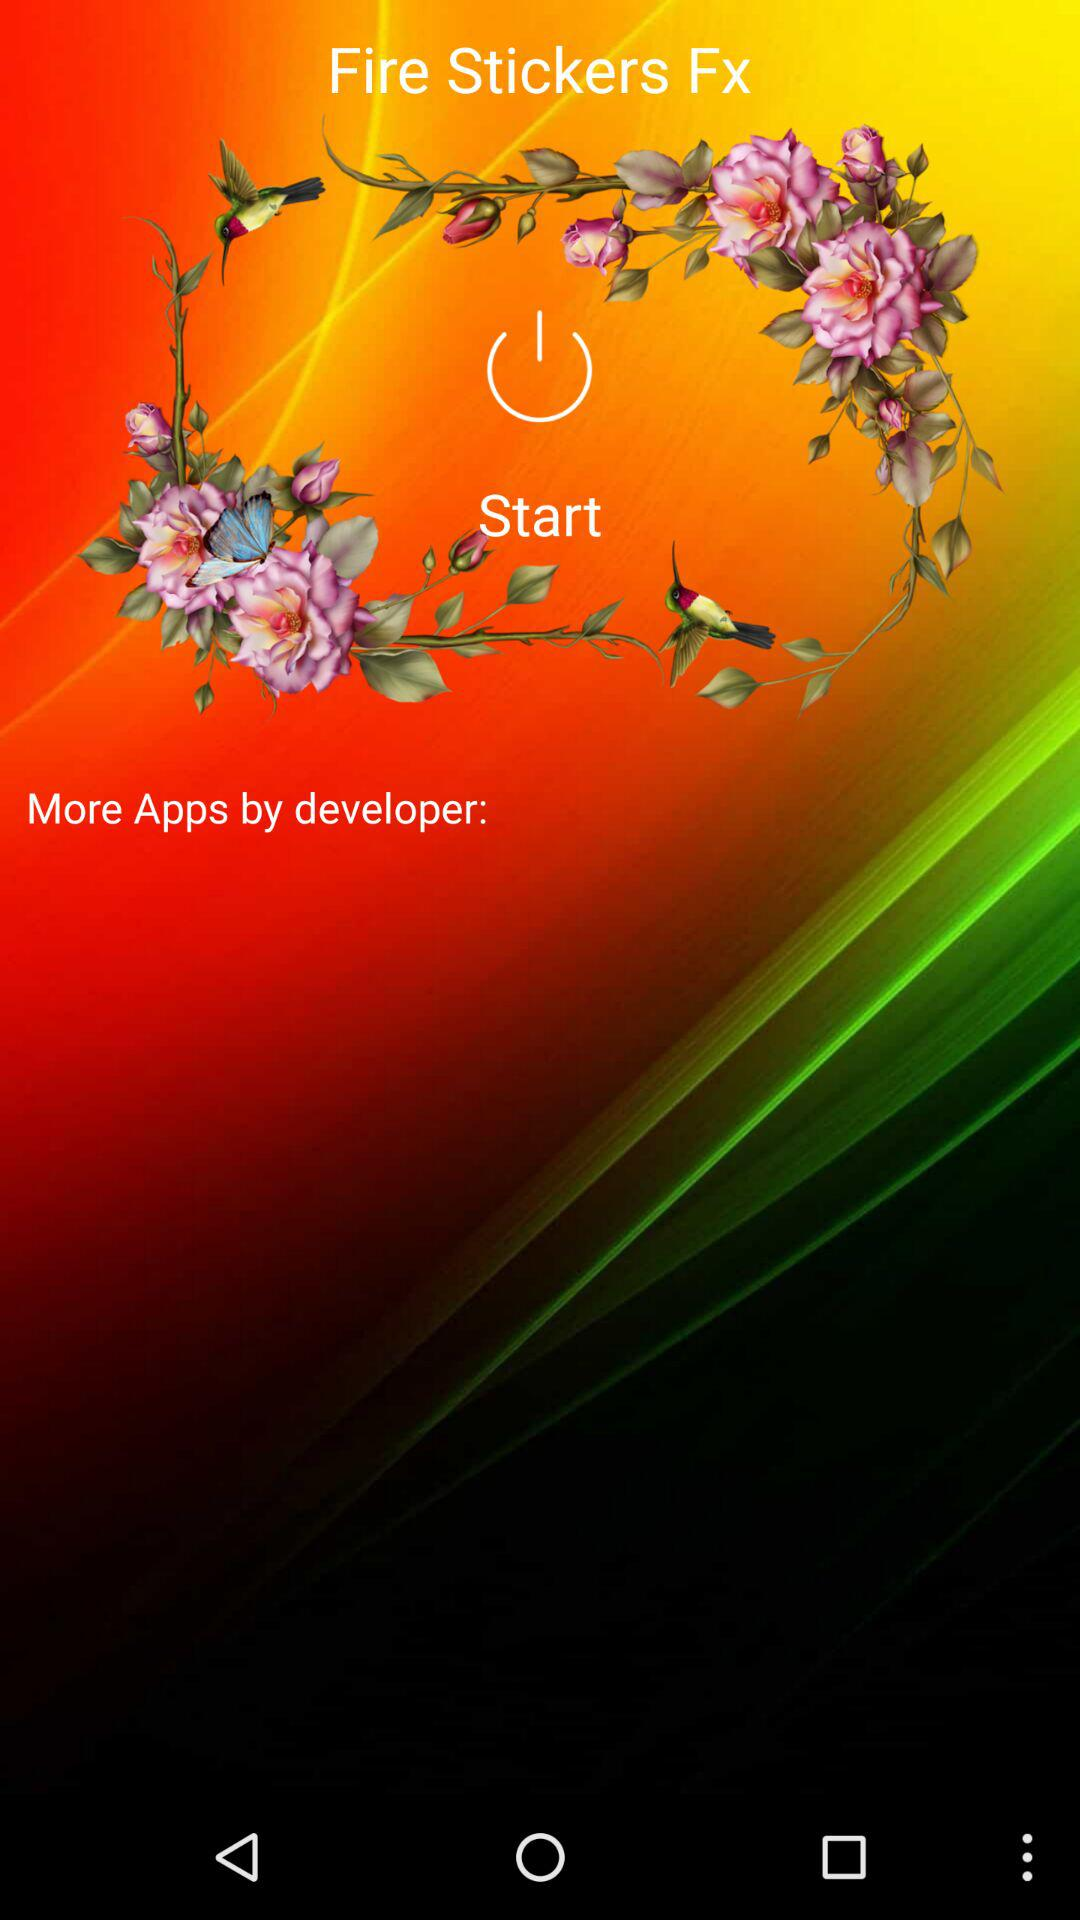What is the app name? The app name is "Fire Stickers Fx". 